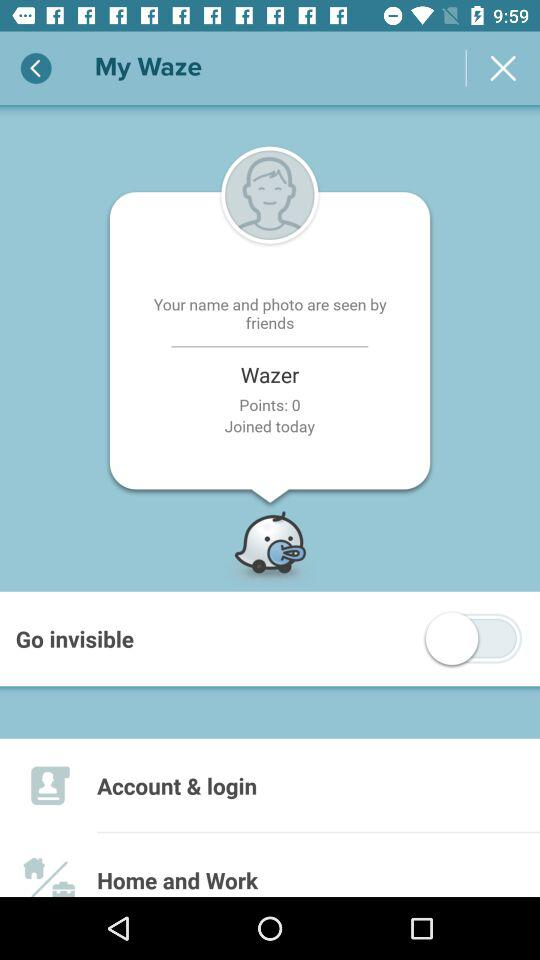How many points does Wazer have? Wazer have 0 points. 